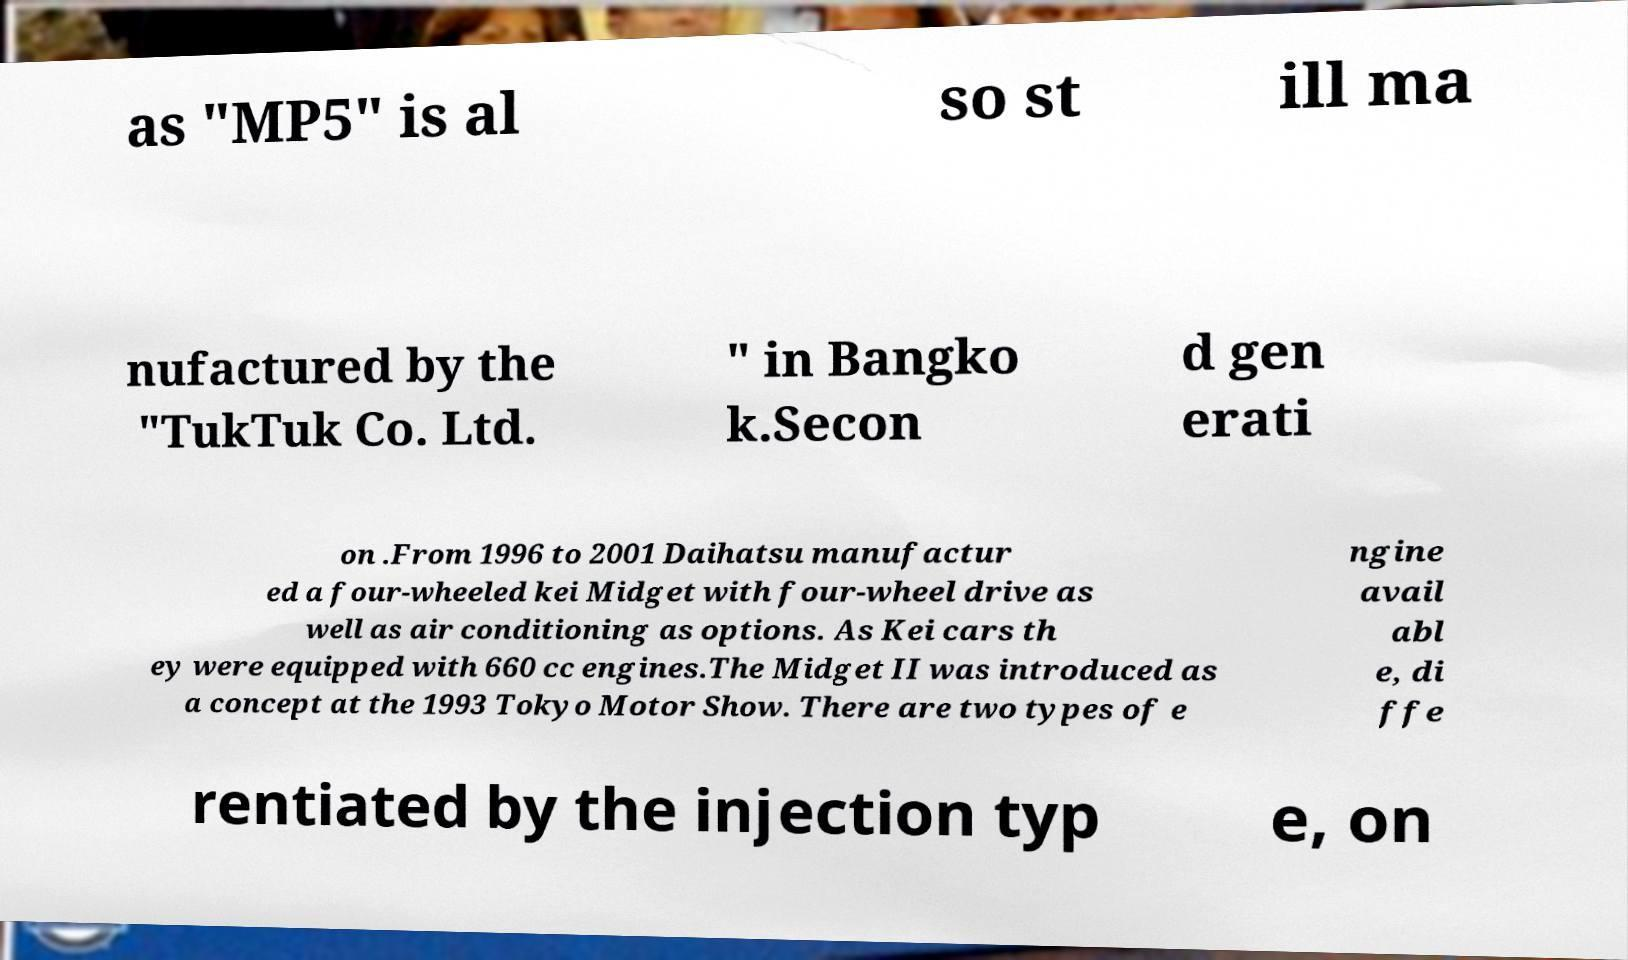What messages or text are displayed in this image? I need them in a readable, typed format. as "MP5" is al so st ill ma nufactured by the "TukTuk Co. Ltd. " in Bangko k.Secon d gen erati on .From 1996 to 2001 Daihatsu manufactur ed a four-wheeled kei Midget with four-wheel drive as well as air conditioning as options. As Kei cars th ey were equipped with 660 cc engines.The Midget II was introduced as a concept at the 1993 Tokyo Motor Show. There are two types of e ngine avail abl e, di ffe rentiated by the injection typ e, on 